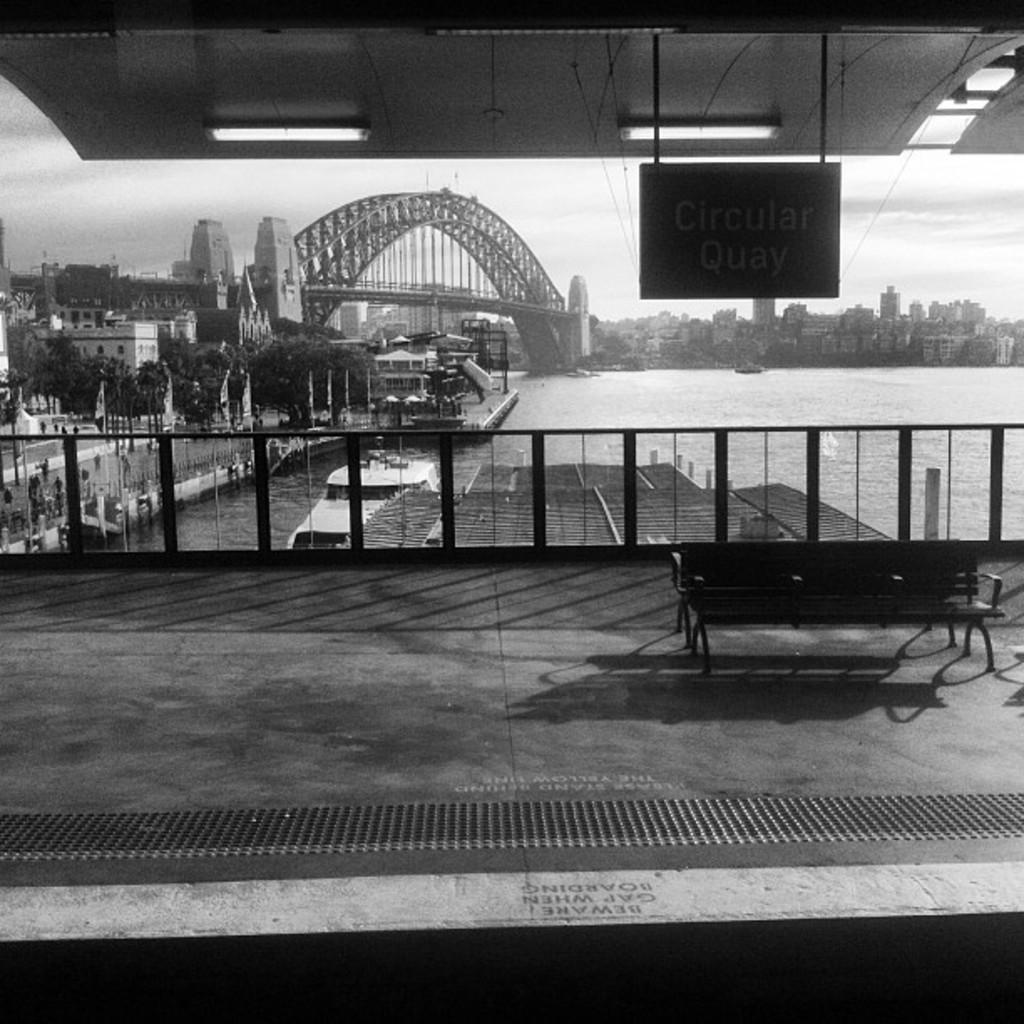In one or two sentences, can you explain what this image depicts? In this picture I can observe a bench on the right side. There is a railing in front of the bench. I can observe a bridge over the river. In this picture I can observe some trees and buildings. In the background there is a sky. This is a black and white image. 